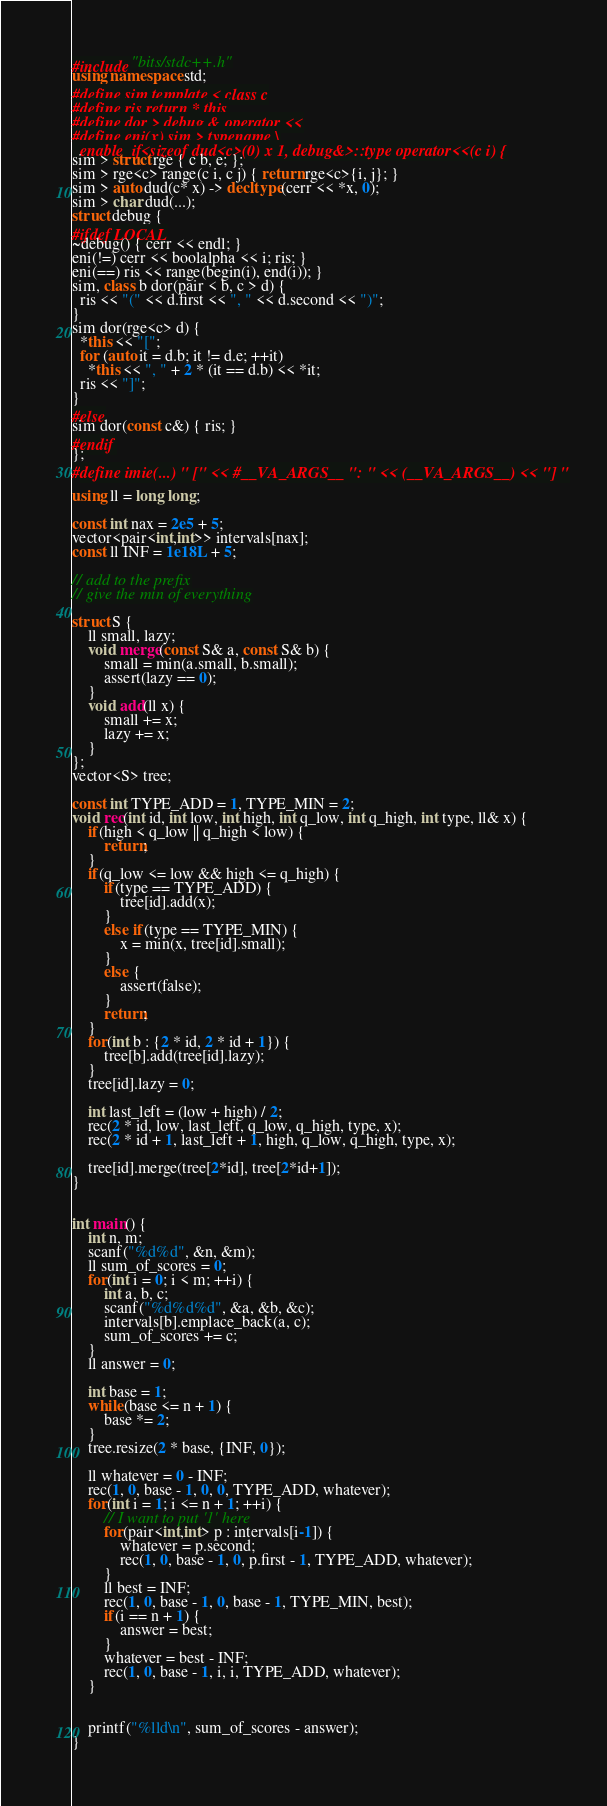Convert code to text. <code><loc_0><loc_0><loc_500><loc_500><_C++_>#include "bits/stdc++.h"
using namespace std;
#define sim template < class c
#define ris return * this
#define dor > debug & operator <<
#define eni(x) sim > typename \
  enable_if<sizeof dud<c>(0) x 1, debug&>::type operator<<(c i) {
sim > struct rge { c b, e; };
sim > rge<c> range(c i, c j) { return rge<c>{i, j}; }
sim > auto dud(c* x) -> decltype(cerr << *x, 0);
sim > char dud(...);
struct debug {
#ifdef LOCAL
~debug() { cerr << endl; }
eni(!=) cerr << boolalpha << i; ris; }
eni(==) ris << range(begin(i), end(i)); }
sim, class b dor(pair < b, c > d) {
  ris << "(" << d.first << ", " << d.second << ")";
}
sim dor(rge<c> d) {
  *this << "[";
  for (auto it = d.b; it != d.e; ++it)
    *this << ", " + 2 * (it == d.b) << *it;
  ris << "]";
}
#else
sim dor(const c&) { ris; }
#endif
};
#define imie(...) " [" << #__VA_ARGS__ ": " << (__VA_ARGS__) << "] "

using ll = long long;

const int nax = 2e5 + 5;
vector<pair<int,int>> intervals[nax];
const ll INF = 1e18L + 5;

// add to the prefix
// give the min of everything

struct S {
    ll small, lazy;
    void merge(const S& a, const S& b) {
        small = min(a.small, b.small);
        assert(lazy == 0);
    }
    void add(ll x) {
        small += x;
        lazy += x;
    }
};
vector<S> tree;

const int TYPE_ADD = 1, TYPE_MIN = 2;
void rec(int id, int low, int high, int q_low, int q_high, int type, ll& x) {
    if(high < q_low || q_high < low) {
        return;
    }
    if(q_low <= low && high <= q_high) {
        if(type == TYPE_ADD) {
            tree[id].add(x);
        }
        else if(type == TYPE_MIN) {
            x = min(x, tree[id].small);
        }
        else {
            assert(false);
        }
        return;
    }
    for(int b : {2 * id, 2 * id + 1}) {
        tree[b].add(tree[id].lazy);
    }
    tree[id].lazy = 0;
    
    int last_left = (low + high) / 2;
    rec(2 * id, low, last_left, q_low, q_high, type, x);
    rec(2 * id + 1, last_left + 1, high, q_low, q_high, type, x);
    
    tree[id].merge(tree[2*id], tree[2*id+1]);
}
        

int main() {
    int n, m;
    scanf("%d%d", &n, &m);
    ll sum_of_scores = 0;
    for(int i = 0; i < m; ++i) {
        int a, b, c;
        scanf("%d%d%d", &a, &b, &c);
        intervals[b].emplace_back(a, c);
        sum_of_scores += c;
    }
    ll answer = 0;
    
    int base = 1;
    while(base <= n + 1) {
        base *= 2;
    }
    tree.resize(2 * base, {INF, 0});
    
    ll whatever = 0 - INF;
    rec(1, 0, base - 1, 0, 0, TYPE_ADD, whatever);
    for(int i = 1; i <= n + 1; ++i) {
        // I want to put '1' here
        for(pair<int,int> p : intervals[i-1]) {
            whatever = p.second;
            rec(1, 0, base - 1, 0, p.first - 1, TYPE_ADD, whatever);
        }
        ll best = INF;
        rec(1, 0, base - 1, 0, base - 1, TYPE_MIN, best);
        if(i == n + 1) {
            answer = best;
        }
        whatever = best - INF;
        rec(1, 0, base - 1, i, i, TYPE_ADD, whatever);
    }
    
    
    printf("%lld\n", sum_of_scores - answer);
}
</code> 